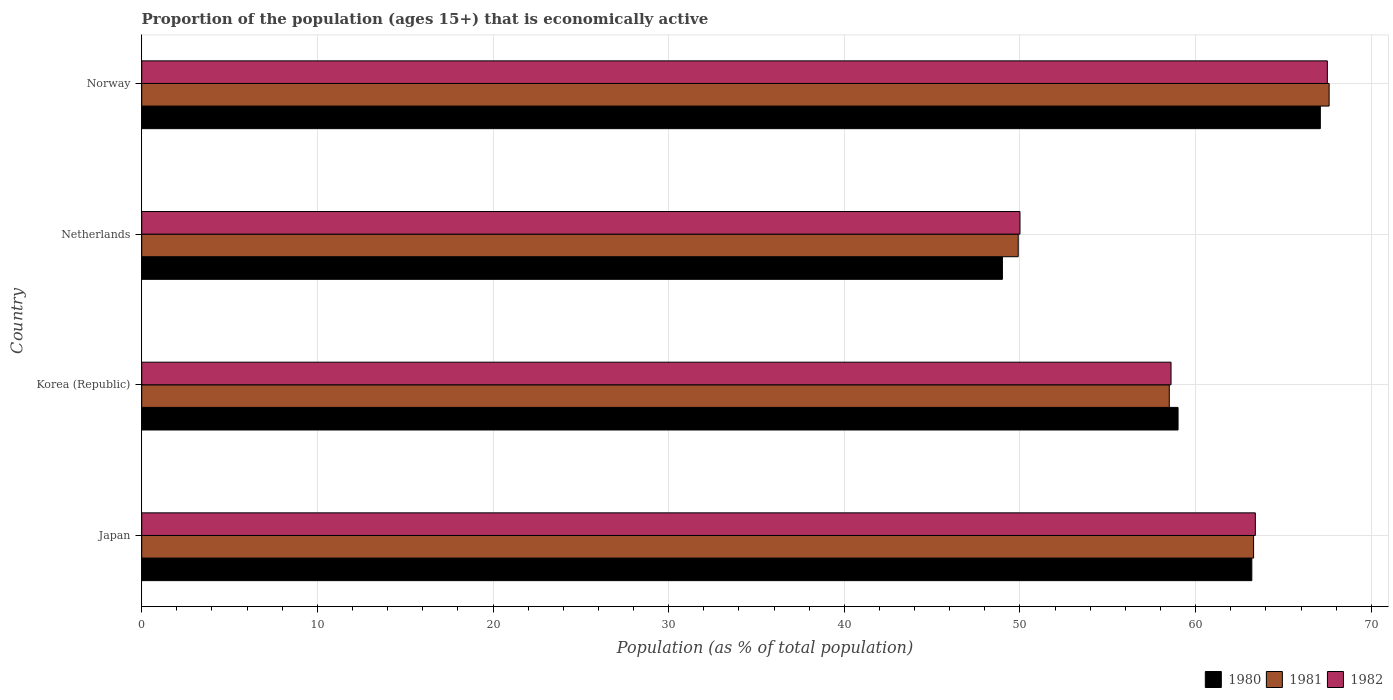How many different coloured bars are there?
Make the answer very short. 3. How many groups of bars are there?
Offer a very short reply. 4. Are the number of bars on each tick of the Y-axis equal?
Provide a succinct answer. Yes. How many bars are there on the 4th tick from the bottom?
Give a very brief answer. 3. What is the label of the 4th group of bars from the top?
Your response must be concise. Japan. Across all countries, what is the maximum proportion of the population that is economically active in 1980?
Offer a very short reply. 67.1. Across all countries, what is the minimum proportion of the population that is economically active in 1981?
Offer a very short reply. 49.9. In which country was the proportion of the population that is economically active in 1981 maximum?
Your response must be concise. Norway. What is the total proportion of the population that is economically active in 1982 in the graph?
Ensure brevity in your answer.  239.5. What is the difference between the proportion of the population that is economically active in 1980 in Japan and that in Korea (Republic)?
Keep it short and to the point. 4.2. What is the difference between the proportion of the population that is economically active in 1981 in Netherlands and the proportion of the population that is economically active in 1982 in Norway?
Give a very brief answer. -17.6. What is the average proportion of the population that is economically active in 1982 per country?
Offer a very short reply. 59.88. What is the difference between the proportion of the population that is economically active in 1981 and proportion of the population that is economically active in 1982 in Korea (Republic)?
Give a very brief answer. -0.1. In how many countries, is the proportion of the population that is economically active in 1982 greater than 68 %?
Your response must be concise. 0. What is the ratio of the proportion of the population that is economically active in 1981 in Netherlands to that in Norway?
Give a very brief answer. 0.74. What is the difference between the highest and the second highest proportion of the population that is economically active in 1980?
Keep it short and to the point. 3.9. What is the difference between the highest and the lowest proportion of the population that is economically active in 1980?
Your answer should be very brief. 18.1. In how many countries, is the proportion of the population that is economically active in 1980 greater than the average proportion of the population that is economically active in 1980 taken over all countries?
Make the answer very short. 2. Is it the case that in every country, the sum of the proportion of the population that is economically active in 1980 and proportion of the population that is economically active in 1981 is greater than the proportion of the population that is economically active in 1982?
Make the answer very short. Yes. How many bars are there?
Provide a short and direct response. 12. Are all the bars in the graph horizontal?
Your response must be concise. Yes. What is the difference between two consecutive major ticks on the X-axis?
Offer a terse response. 10. Are the values on the major ticks of X-axis written in scientific E-notation?
Offer a very short reply. No. What is the title of the graph?
Provide a short and direct response. Proportion of the population (ages 15+) that is economically active. Does "2012" appear as one of the legend labels in the graph?
Your response must be concise. No. What is the label or title of the X-axis?
Provide a succinct answer. Population (as % of total population). What is the label or title of the Y-axis?
Your answer should be very brief. Country. What is the Population (as % of total population) of 1980 in Japan?
Your answer should be compact. 63.2. What is the Population (as % of total population) in 1981 in Japan?
Your answer should be very brief. 63.3. What is the Population (as % of total population) of 1982 in Japan?
Your answer should be very brief. 63.4. What is the Population (as % of total population) of 1980 in Korea (Republic)?
Offer a very short reply. 59. What is the Population (as % of total population) of 1981 in Korea (Republic)?
Your response must be concise. 58.5. What is the Population (as % of total population) in 1982 in Korea (Republic)?
Provide a succinct answer. 58.6. What is the Population (as % of total population) in 1981 in Netherlands?
Your answer should be very brief. 49.9. What is the Population (as % of total population) of 1980 in Norway?
Keep it short and to the point. 67.1. What is the Population (as % of total population) of 1981 in Norway?
Offer a terse response. 67.6. What is the Population (as % of total population) in 1982 in Norway?
Offer a terse response. 67.5. Across all countries, what is the maximum Population (as % of total population) in 1980?
Provide a succinct answer. 67.1. Across all countries, what is the maximum Population (as % of total population) of 1981?
Give a very brief answer. 67.6. Across all countries, what is the maximum Population (as % of total population) of 1982?
Provide a short and direct response. 67.5. Across all countries, what is the minimum Population (as % of total population) of 1981?
Ensure brevity in your answer.  49.9. What is the total Population (as % of total population) in 1980 in the graph?
Offer a terse response. 238.3. What is the total Population (as % of total population) of 1981 in the graph?
Give a very brief answer. 239.3. What is the total Population (as % of total population) in 1982 in the graph?
Offer a very short reply. 239.5. What is the difference between the Population (as % of total population) in 1980 in Japan and that in Korea (Republic)?
Keep it short and to the point. 4.2. What is the difference between the Population (as % of total population) in 1981 in Japan and that in Korea (Republic)?
Keep it short and to the point. 4.8. What is the difference between the Population (as % of total population) in 1980 in Japan and that in Netherlands?
Give a very brief answer. 14.2. What is the difference between the Population (as % of total population) of 1980 in Japan and that in Norway?
Your answer should be compact. -3.9. What is the difference between the Population (as % of total population) of 1980 in Korea (Republic) and that in Netherlands?
Keep it short and to the point. 10. What is the difference between the Population (as % of total population) in 1982 in Korea (Republic) and that in Netherlands?
Ensure brevity in your answer.  8.6. What is the difference between the Population (as % of total population) of 1981 in Korea (Republic) and that in Norway?
Provide a succinct answer. -9.1. What is the difference between the Population (as % of total population) of 1982 in Korea (Republic) and that in Norway?
Your response must be concise. -8.9. What is the difference between the Population (as % of total population) of 1980 in Netherlands and that in Norway?
Ensure brevity in your answer.  -18.1. What is the difference between the Population (as % of total population) of 1981 in Netherlands and that in Norway?
Offer a very short reply. -17.7. What is the difference between the Population (as % of total population) in 1982 in Netherlands and that in Norway?
Your response must be concise. -17.5. What is the difference between the Population (as % of total population) in 1980 in Japan and the Population (as % of total population) in 1982 in Korea (Republic)?
Make the answer very short. 4.6. What is the difference between the Population (as % of total population) in 1980 in Japan and the Population (as % of total population) in 1981 in Netherlands?
Your answer should be very brief. 13.3. What is the difference between the Population (as % of total population) in 1980 in Japan and the Population (as % of total population) in 1982 in Netherlands?
Your answer should be very brief. 13.2. What is the difference between the Population (as % of total population) of 1981 in Japan and the Population (as % of total population) of 1982 in Netherlands?
Provide a short and direct response. 13.3. What is the difference between the Population (as % of total population) in 1980 in Japan and the Population (as % of total population) in 1982 in Norway?
Offer a terse response. -4.3. What is the difference between the Population (as % of total population) of 1980 in Korea (Republic) and the Population (as % of total population) of 1981 in Netherlands?
Your response must be concise. 9.1. What is the difference between the Population (as % of total population) of 1981 in Korea (Republic) and the Population (as % of total population) of 1982 in Netherlands?
Keep it short and to the point. 8.5. What is the difference between the Population (as % of total population) in 1980 in Korea (Republic) and the Population (as % of total population) in 1981 in Norway?
Provide a short and direct response. -8.6. What is the difference between the Population (as % of total population) in 1981 in Korea (Republic) and the Population (as % of total population) in 1982 in Norway?
Provide a succinct answer. -9. What is the difference between the Population (as % of total population) in 1980 in Netherlands and the Population (as % of total population) in 1981 in Norway?
Offer a very short reply. -18.6. What is the difference between the Population (as % of total population) in 1980 in Netherlands and the Population (as % of total population) in 1982 in Norway?
Provide a short and direct response. -18.5. What is the difference between the Population (as % of total population) in 1981 in Netherlands and the Population (as % of total population) in 1982 in Norway?
Keep it short and to the point. -17.6. What is the average Population (as % of total population) of 1980 per country?
Your response must be concise. 59.58. What is the average Population (as % of total population) in 1981 per country?
Offer a very short reply. 59.83. What is the average Population (as % of total population) in 1982 per country?
Make the answer very short. 59.88. What is the difference between the Population (as % of total population) in 1980 and Population (as % of total population) in 1982 in Japan?
Your response must be concise. -0.2. What is the difference between the Population (as % of total population) in 1981 and Population (as % of total population) in 1982 in Japan?
Provide a succinct answer. -0.1. What is the difference between the Population (as % of total population) in 1980 and Population (as % of total population) in 1981 in Korea (Republic)?
Keep it short and to the point. 0.5. What is the difference between the Population (as % of total population) in 1981 and Population (as % of total population) in 1982 in Korea (Republic)?
Your response must be concise. -0.1. What is the difference between the Population (as % of total population) in 1980 and Population (as % of total population) in 1981 in Netherlands?
Keep it short and to the point. -0.9. What is the difference between the Population (as % of total population) in 1980 and Population (as % of total population) in 1981 in Norway?
Keep it short and to the point. -0.5. What is the difference between the Population (as % of total population) in 1981 and Population (as % of total population) in 1982 in Norway?
Your response must be concise. 0.1. What is the ratio of the Population (as % of total population) in 1980 in Japan to that in Korea (Republic)?
Your answer should be very brief. 1.07. What is the ratio of the Population (as % of total population) in 1981 in Japan to that in Korea (Republic)?
Your response must be concise. 1.08. What is the ratio of the Population (as % of total population) of 1982 in Japan to that in Korea (Republic)?
Provide a succinct answer. 1.08. What is the ratio of the Population (as % of total population) in 1980 in Japan to that in Netherlands?
Provide a short and direct response. 1.29. What is the ratio of the Population (as % of total population) in 1981 in Japan to that in Netherlands?
Provide a short and direct response. 1.27. What is the ratio of the Population (as % of total population) in 1982 in Japan to that in Netherlands?
Your answer should be compact. 1.27. What is the ratio of the Population (as % of total population) of 1980 in Japan to that in Norway?
Your answer should be very brief. 0.94. What is the ratio of the Population (as % of total population) of 1981 in Japan to that in Norway?
Your response must be concise. 0.94. What is the ratio of the Population (as % of total population) of 1982 in Japan to that in Norway?
Your response must be concise. 0.94. What is the ratio of the Population (as % of total population) of 1980 in Korea (Republic) to that in Netherlands?
Provide a short and direct response. 1.2. What is the ratio of the Population (as % of total population) in 1981 in Korea (Republic) to that in Netherlands?
Make the answer very short. 1.17. What is the ratio of the Population (as % of total population) of 1982 in Korea (Republic) to that in Netherlands?
Keep it short and to the point. 1.17. What is the ratio of the Population (as % of total population) in 1980 in Korea (Republic) to that in Norway?
Give a very brief answer. 0.88. What is the ratio of the Population (as % of total population) of 1981 in Korea (Republic) to that in Norway?
Ensure brevity in your answer.  0.87. What is the ratio of the Population (as % of total population) in 1982 in Korea (Republic) to that in Norway?
Your answer should be compact. 0.87. What is the ratio of the Population (as % of total population) in 1980 in Netherlands to that in Norway?
Provide a short and direct response. 0.73. What is the ratio of the Population (as % of total population) in 1981 in Netherlands to that in Norway?
Your answer should be very brief. 0.74. What is the ratio of the Population (as % of total population) of 1982 in Netherlands to that in Norway?
Your response must be concise. 0.74. What is the difference between the highest and the second highest Population (as % of total population) in 1981?
Provide a short and direct response. 4.3. 